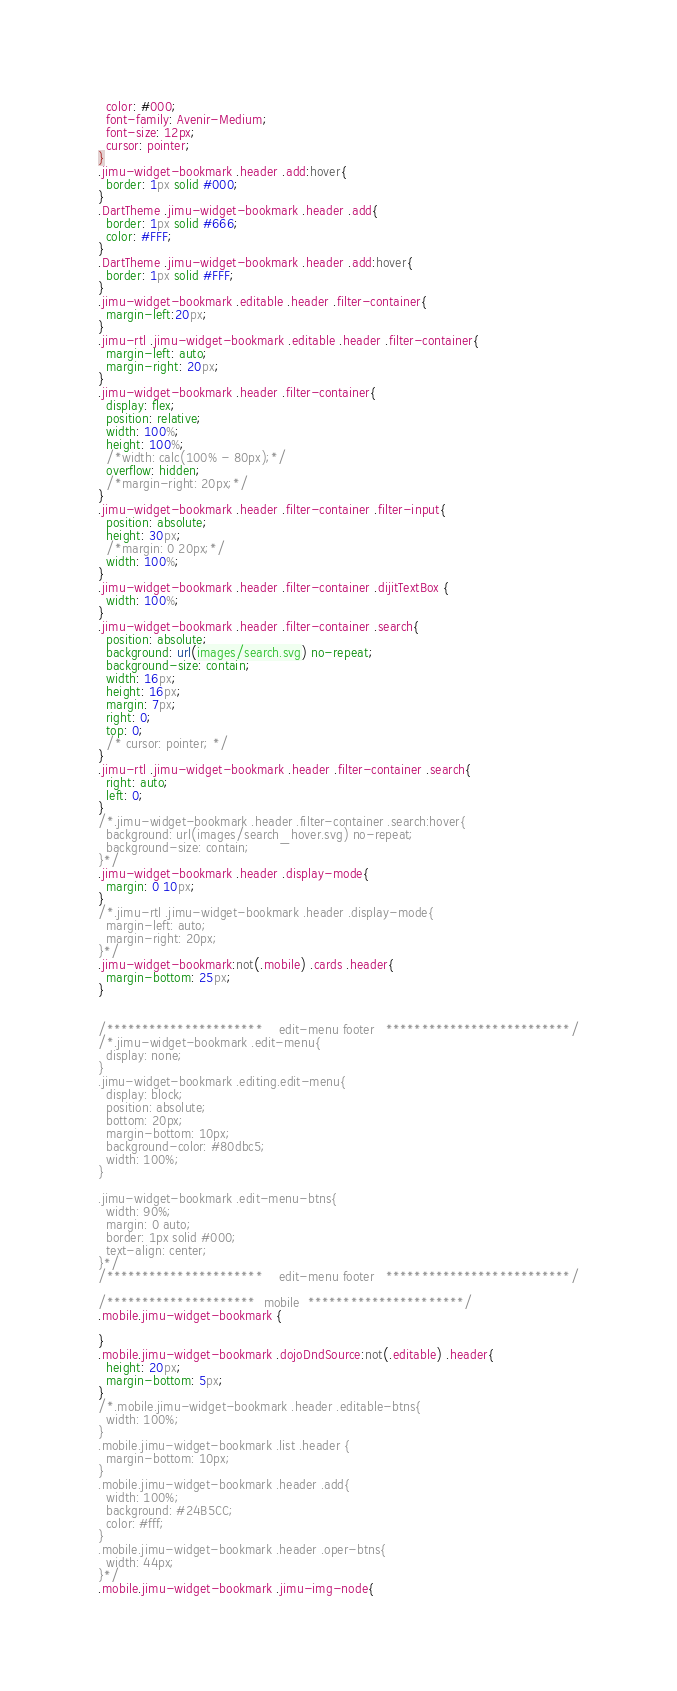<code> <loc_0><loc_0><loc_500><loc_500><_CSS_>  color: #000;
  font-family: Avenir-Medium;
  font-size: 12px;
  cursor: pointer;
}
.jimu-widget-bookmark .header .add:hover{
  border: 1px solid #000;
}
.DartTheme .jimu-widget-bookmark .header .add{
  border: 1px solid #666;
  color: #FFF;
}
.DartTheme .jimu-widget-bookmark .header .add:hover{
  border: 1px solid #FFF;
}
.jimu-widget-bookmark .editable .header .filter-container{
  margin-left:20px;
}
.jimu-rtl .jimu-widget-bookmark .editable .header .filter-container{
  margin-left: auto;
  margin-right: 20px;
}
.jimu-widget-bookmark .header .filter-container{
  display: flex;
  position: relative;
  width: 100%;
  height: 100%;
  /*width: calc(100% - 80px);*/
  overflow: hidden;
  /*margin-right: 20px;*/
}
.jimu-widget-bookmark .header .filter-container .filter-input{
  position: absolute;
  height: 30px;
  /*margin: 0 20px;*/
  width: 100%;
}
.jimu-widget-bookmark .header .filter-container .dijitTextBox {
  width: 100%;
}
.jimu-widget-bookmark .header .filter-container .search{
  position: absolute;
  background: url(images/search.svg) no-repeat;
  background-size: contain;
  width: 16px;
  height: 16px;
  margin: 7px;
  right: 0;
  top: 0;
  /* cursor: pointer; */
}
.jimu-rtl .jimu-widget-bookmark .header .filter-container .search{
  right: auto;
  left: 0;
}
/*.jimu-widget-bookmark .header .filter-container .search:hover{
  background: url(images/search_hover.svg) no-repeat;
  background-size: contain;
}*/
.jimu-widget-bookmark .header .display-mode{
  margin: 0 10px;
}
/*.jimu-rtl .jimu-widget-bookmark .header .display-mode{
  margin-left: auto;
  margin-right: 20px;
}*/
.jimu-widget-bookmark:not(.mobile) .cards .header{
  margin-bottom: 25px;
}


/**********************    edit-menu footer   **************************/
/*.jimu-widget-bookmark .edit-menu{
  display: none;
}
.jimu-widget-bookmark .editing.edit-menu{
  display: block;
  position: absolute;
  bottom: 20px;
  margin-bottom: 10px;
  background-color: #80dbc5;
  width: 100%;
}

.jimu-widget-bookmark .edit-menu-btns{
  width: 90%;
  margin: 0 auto;
  border: 1px solid #000;
  text-align: center;
}*/
/**********************    edit-menu footer   **************************/

/*********************  mobile  **********************/
.mobile.jimu-widget-bookmark {

}
.mobile.jimu-widget-bookmark .dojoDndSource:not(.editable) .header{
  height: 20px;
  margin-bottom: 5px;
}
/*.mobile.jimu-widget-bookmark .header .editable-btns{
  width: 100%;
}
.mobile.jimu-widget-bookmark .list .header {
  margin-bottom: 10px;
}
.mobile.jimu-widget-bookmark .header .add{
  width: 100%;
  background: #24B5CC;
  color: #fff;
}
.mobile.jimu-widget-bookmark .header .oper-btns{
  width: 44px;
}*/
.mobile.jimu-widget-bookmark .jimu-img-node{</code> 